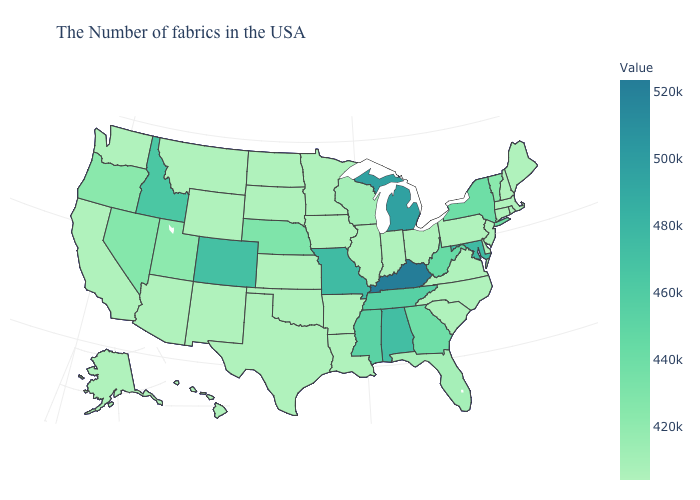Which states have the highest value in the USA?
Be succinct. Kentucky. Which states have the highest value in the USA?
Keep it brief. Kentucky. Among the states that border Washington , which have the lowest value?
Keep it brief. Oregon. Does Alaska have a lower value than Maryland?
Concise answer only. Yes. Is the legend a continuous bar?
Be succinct. Yes. Which states have the highest value in the USA?
Quick response, please. Kentucky. Is the legend a continuous bar?
Give a very brief answer. Yes. 